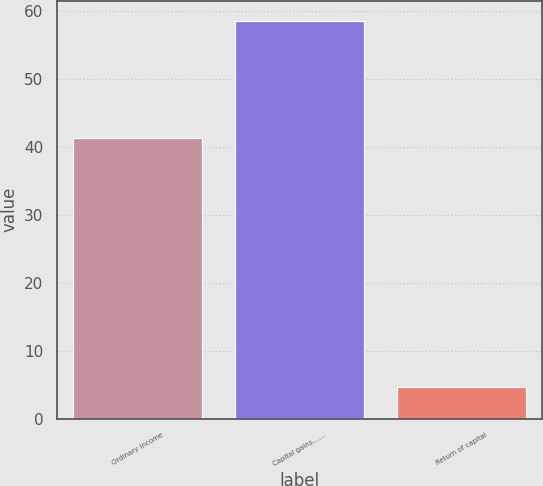Convert chart to OTSL. <chart><loc_0><loc_0><loc_500><loc_500><bar_chart><fcel>Ordinary income<fcel>Capital gains……<fcel>Return of capital<nl><fcel>41.4<fcel>58.6<fcel>4.74<nl></chart> 